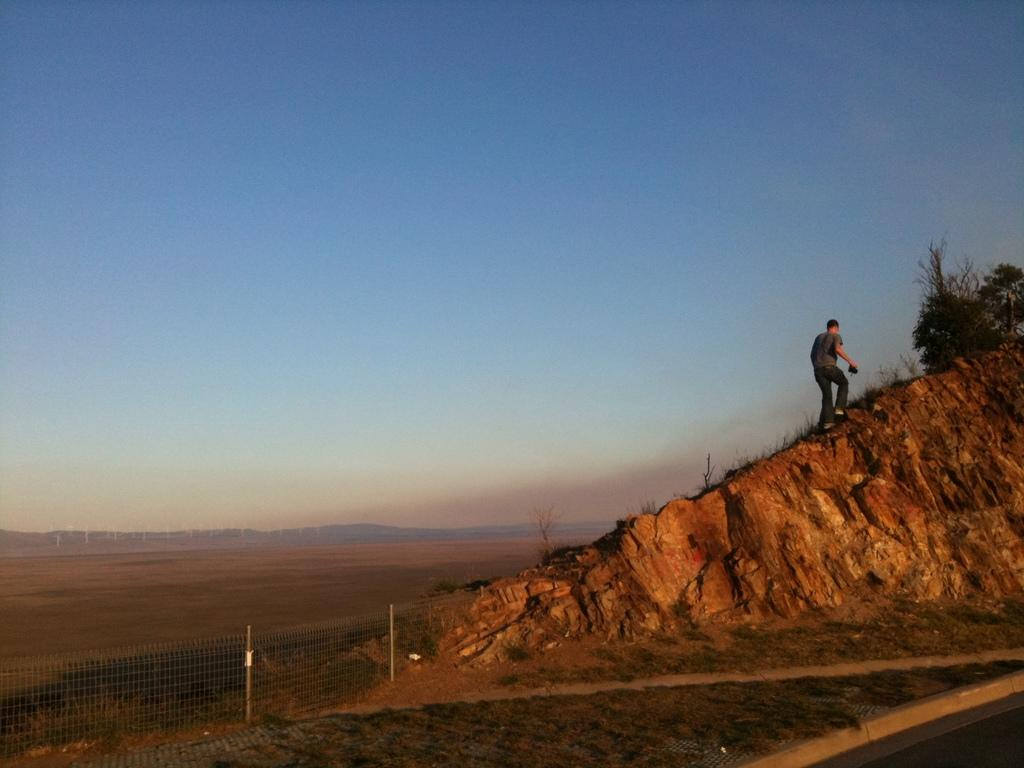What is the man in the picture doing? The man is climbing a mountain in the picture. What can be seen in the image besides the man climbing the mountain? There are plants visible in the image, as well as a fence. What is the background of the image like? There is a large open area in the background of the image. How is the weather in the image? The sky is clear in the image, suggesting good weather. What type of rod can be seen in the image? There is no rod present in the image. What nation is the man representing while climbing the mountain in the image? The image does not provide information about the man's nationality or the nation he might be representing. 